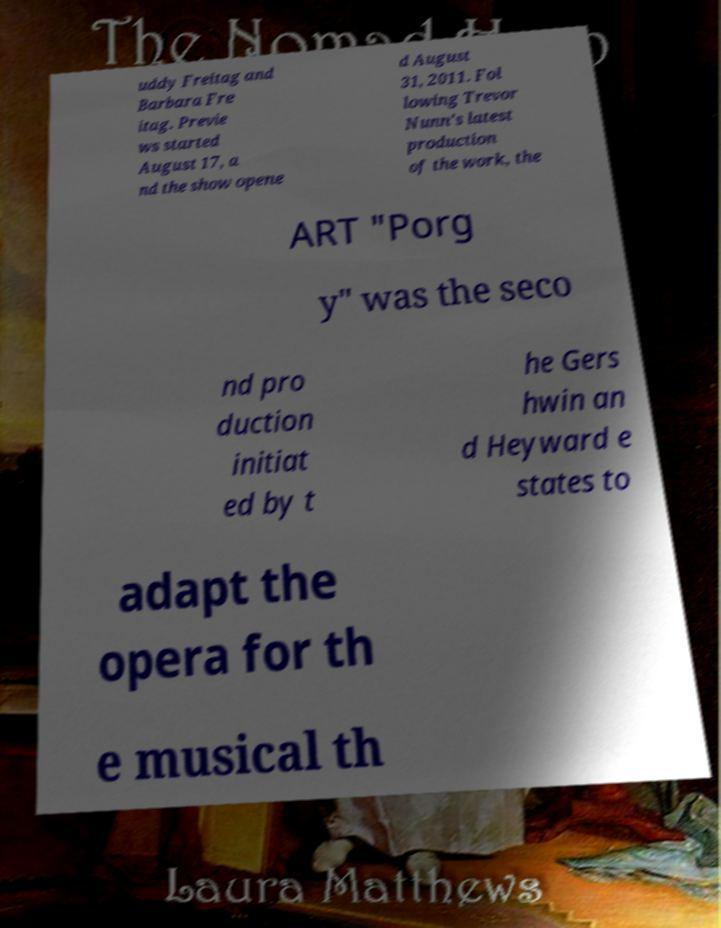There's text embedded in this image that I need extracted. Can you transcribe it verbatim? uddy Freitag and Barbara Fre itag. Previe ws started August 17, a nd the show opene d August 31, 2011. Fol lowing Trevor Nunn's latest production of the work, the ART "Porg y" was the seco nd pro duction initiat ed by t he Gers hwin an d Heyward e states to adapt the opera for th e musical th 